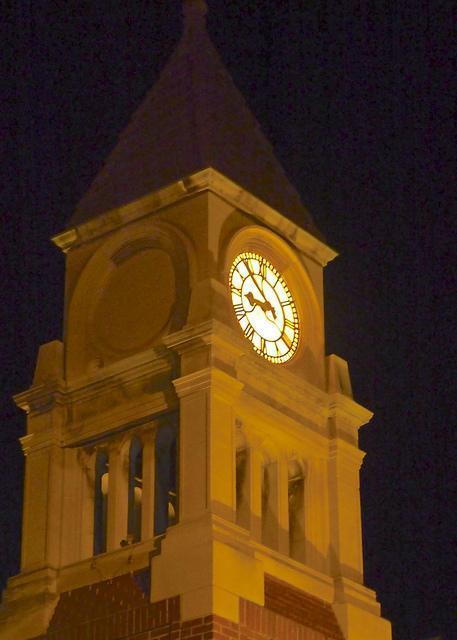How many clocks are shown on the building?
Give a very brief answer. 1. How many clocks can you see?
Give a very brief answer. 1. 